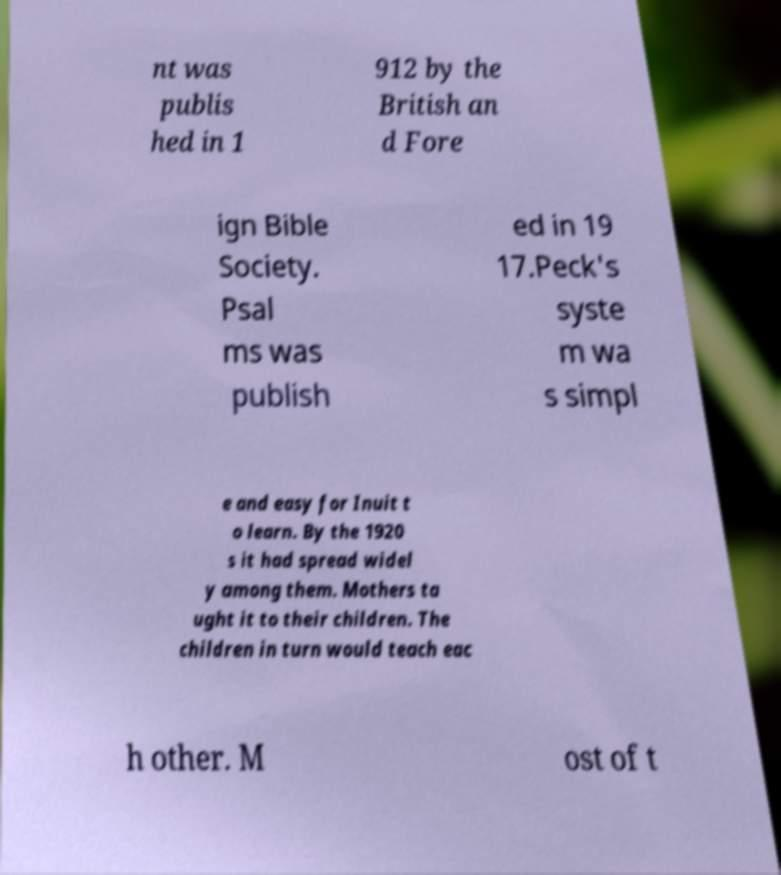Can you read and provide the text displayed in the image?This photo seems to have some interesting text. Can you extract and type it out for me? nt was publis hed in 1 912 by the British an d Fore ign Bible Society. Psal ms was publish ed in 19 17.Peck's syste m wa s simpl e and easy for Inuit t o learn. By the 1920 s it had spread widel y among them. Mothers ta ught it to their children. The children in turn would teach eac h other. M ost of t 